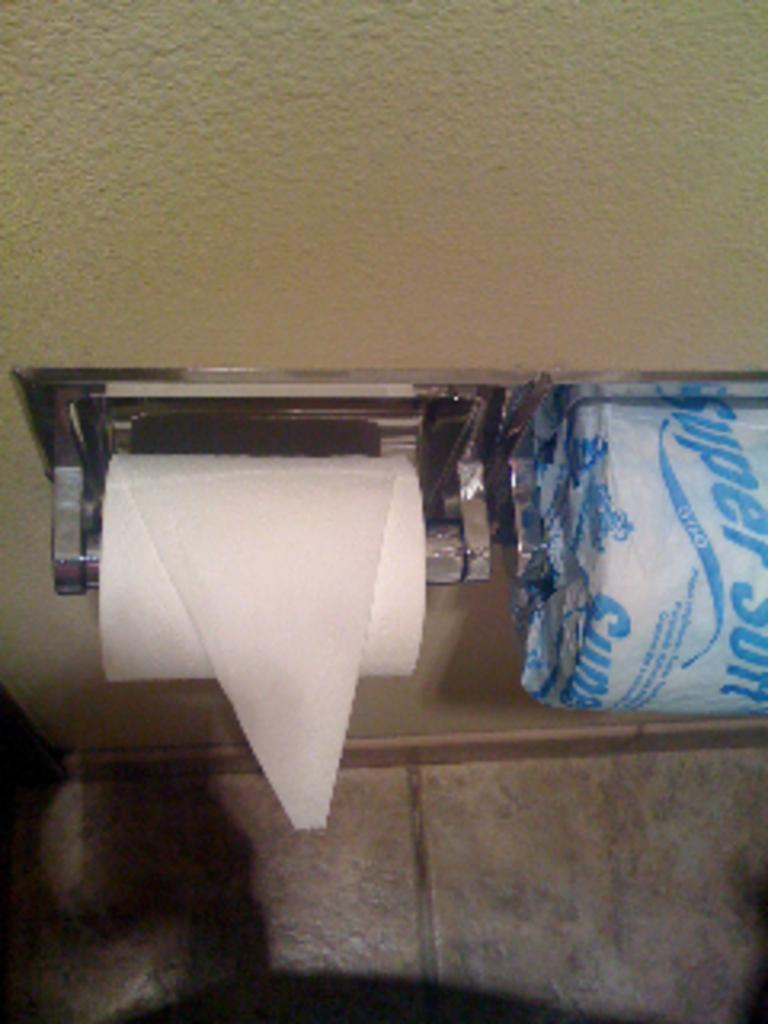<image>
Offer a succinct explanation of the picture presented. a close up of toilet paper with words Super Soft on hangers 